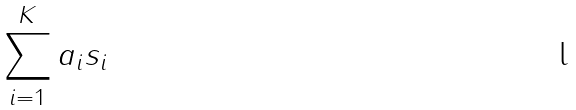<formula> <loc_0><loc_0><loc_500><loc_500>\sum _ { i = 1 } ^ { K } a _ { i } s _ { i }</formula> 